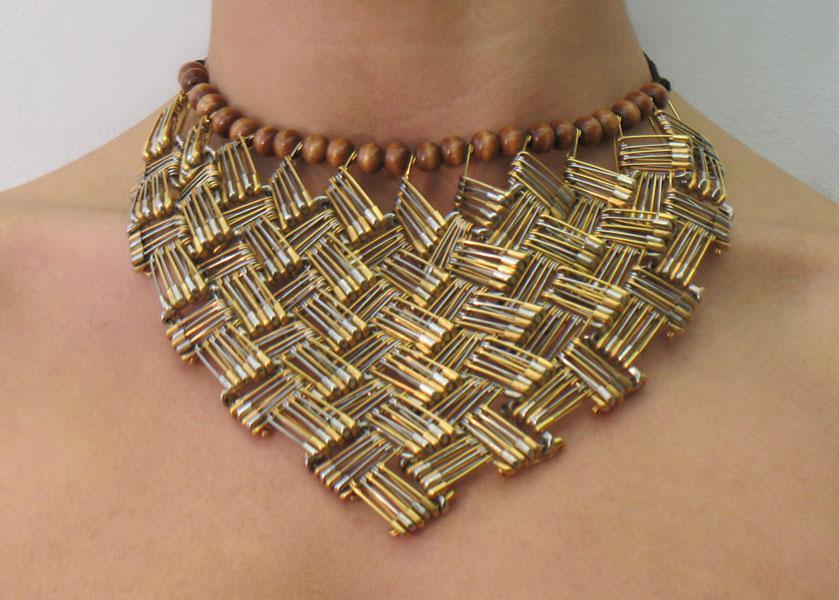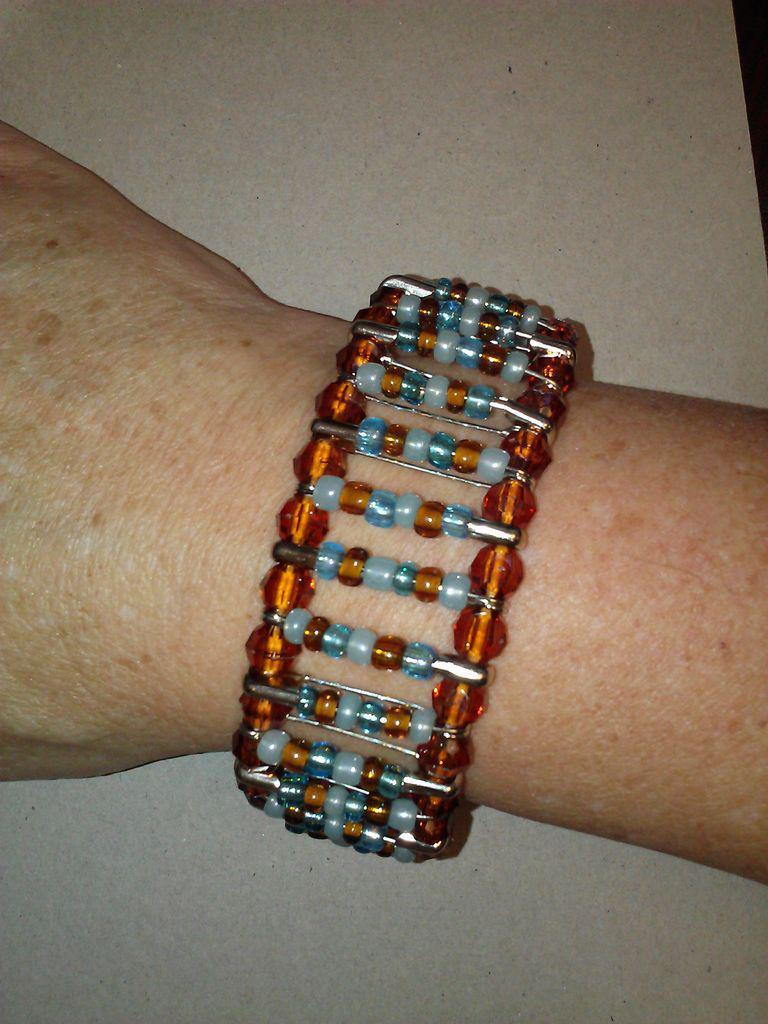The first image is the image on the left, the second image is the image on the right. For the images shown, is this caption "A necklace shown on a neck contains a pattern of square shapes made by repeating safety pin rows and contains gold and silver pins without beads strung on them." true? Answer yes or no. Yes. 